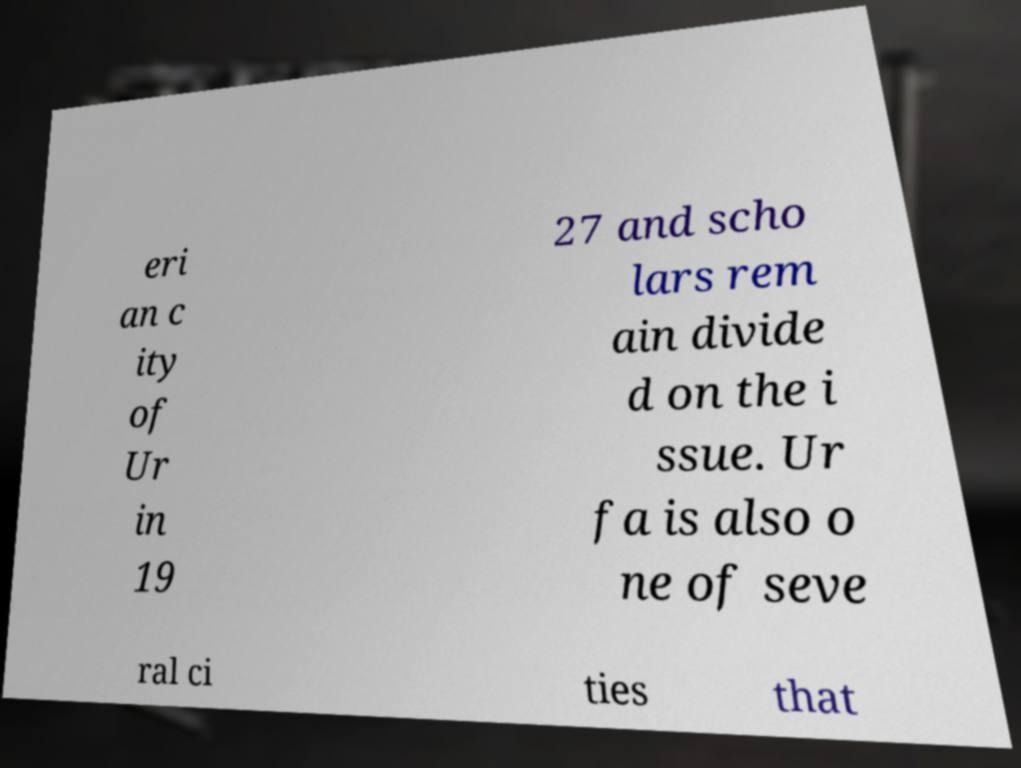Could you assist in decoding the text presented in this image and type it out clearly? eri an c ity of Ur in 19 27 and scho lars rem ain divide d on the i ssue. Ur fa is also o ne of seve ral ci ties that 